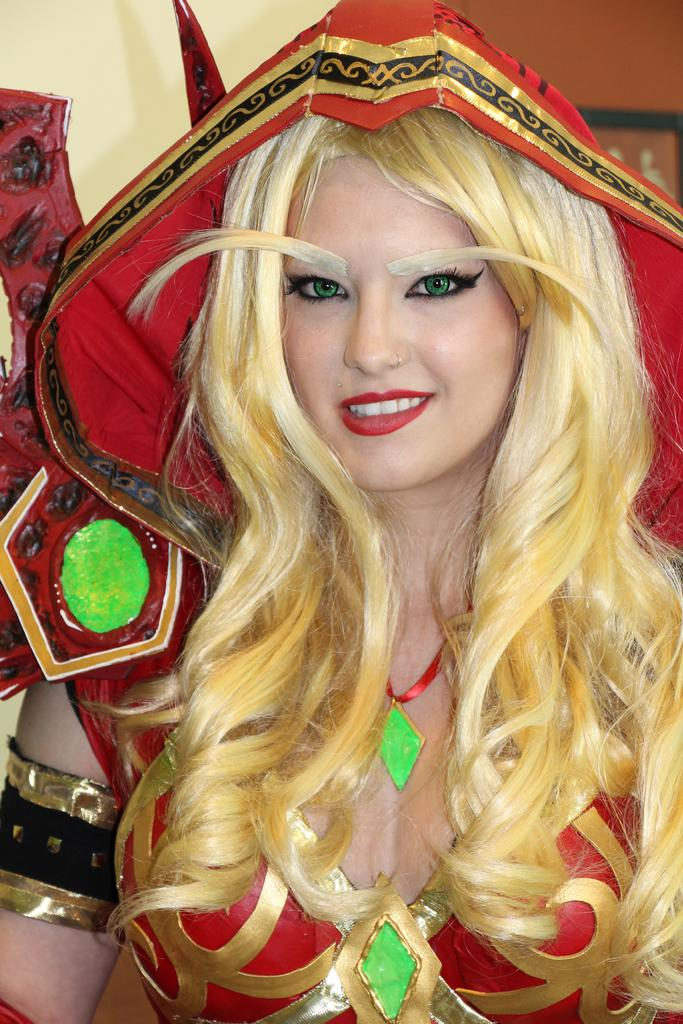Who is present in the image? There is a person in the image. What is the person wearing? The person is wearing a fancy dress. What color is the fancy dress? The fancy dress is colored red. What year is the boat mentioned in the image? There is no boat or mention of a year in the image. 